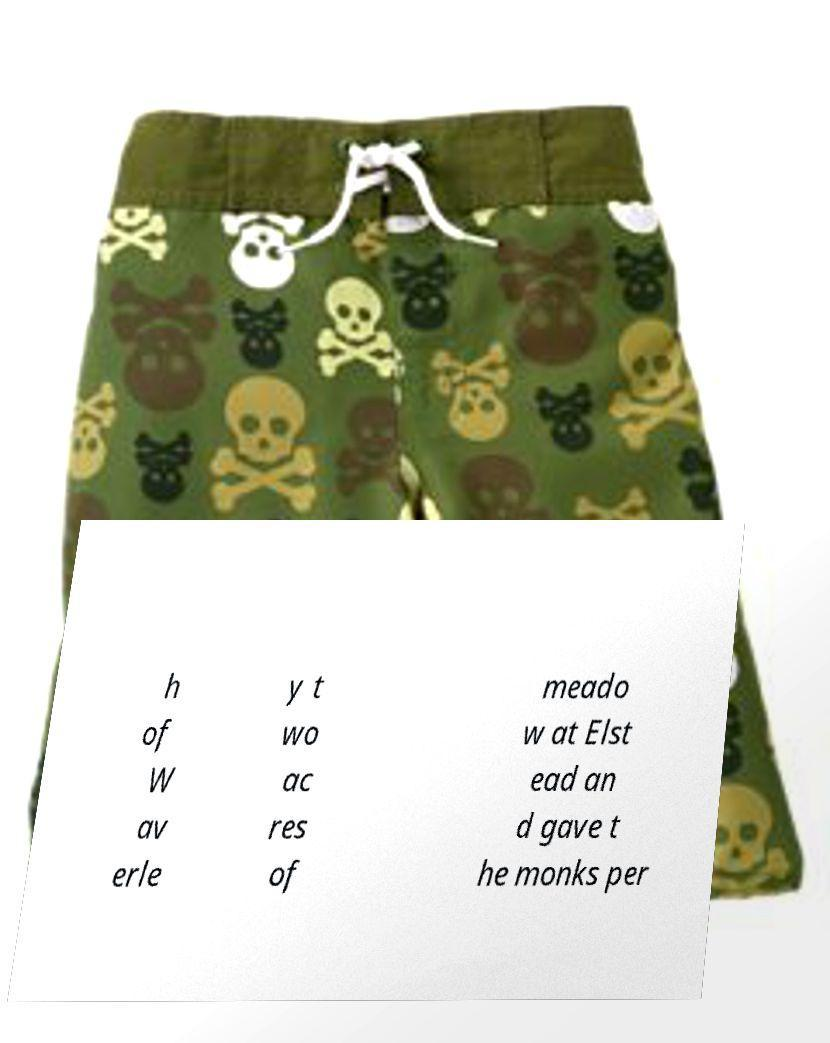Could you extract and type out the text from this image? h of W av erle y t wo ac res of meado w at Elst ead an d gave t he monks per 